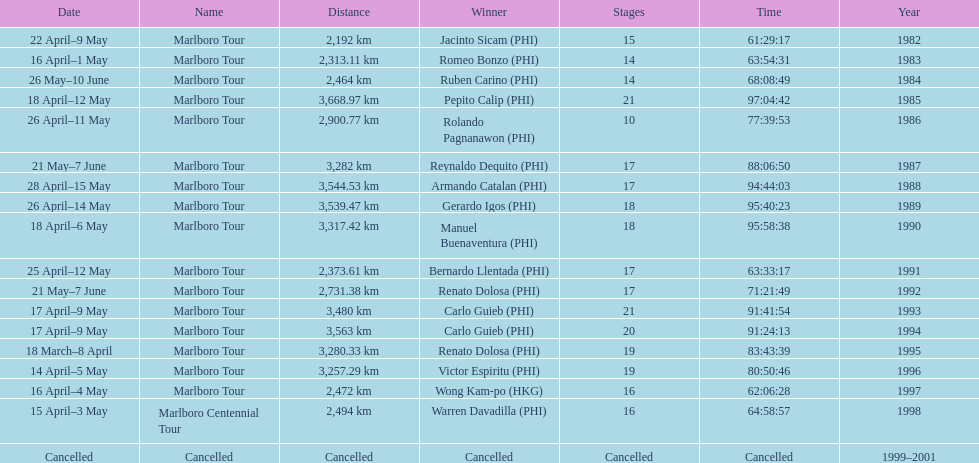What was the total number of winners before the tour was canceled? 17. 